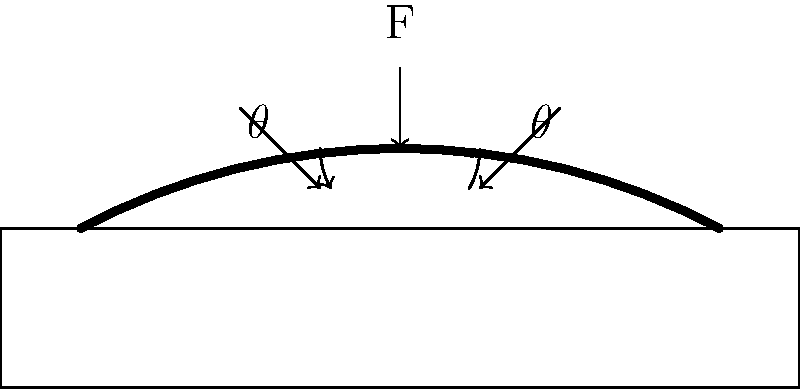In pressure ulcer prevention, patient repositioning is crucial. The diagram shows a patient being turned at an angle $\theta$ from the horizontal. If the patient's weight is 80 kg and the turning angle is 30°, what is the magnitude of the normal force (F) exerted on the patient's skin by the bed surface? To solve this problem, we'll follow these steps:

1. Understand the forces involved:
   - The patient's weight (W) acts vertically downward.
   - The normal force (F) from the bed surface acts perpendicular to the bed.

2. Use trigonometry to find the component of weight perpendicular to the bed:
   - The perpendicular component is $W \cos(\theta)$

3. Apply Newton's Second Law:
   - In equilibrium, the normal force must equal the perpendicular component of weight.
   - $F = W \cos(\theta)$

4. Calculate the normal force:
   - Patient's weight: $W = 80 \text{ kg} \times 9.8 \text{ m/s}^2 = 784 \text{ N}$
   - Turning angle: $\theta = 30°$
   - $F = 784 \text{ N} \times \cos(30°)$
   - $F = 784 \text{ N} \times 0.866 = 679.1 \text{ N}$

5. Round to a reasonable number of significant figures:
   - $F \approx 679 \text{ N}$

This reduced normal force helps prevent pressure ulcers by decreasing the pressure on any single area of the patient's skin.
Answer: 679 N 